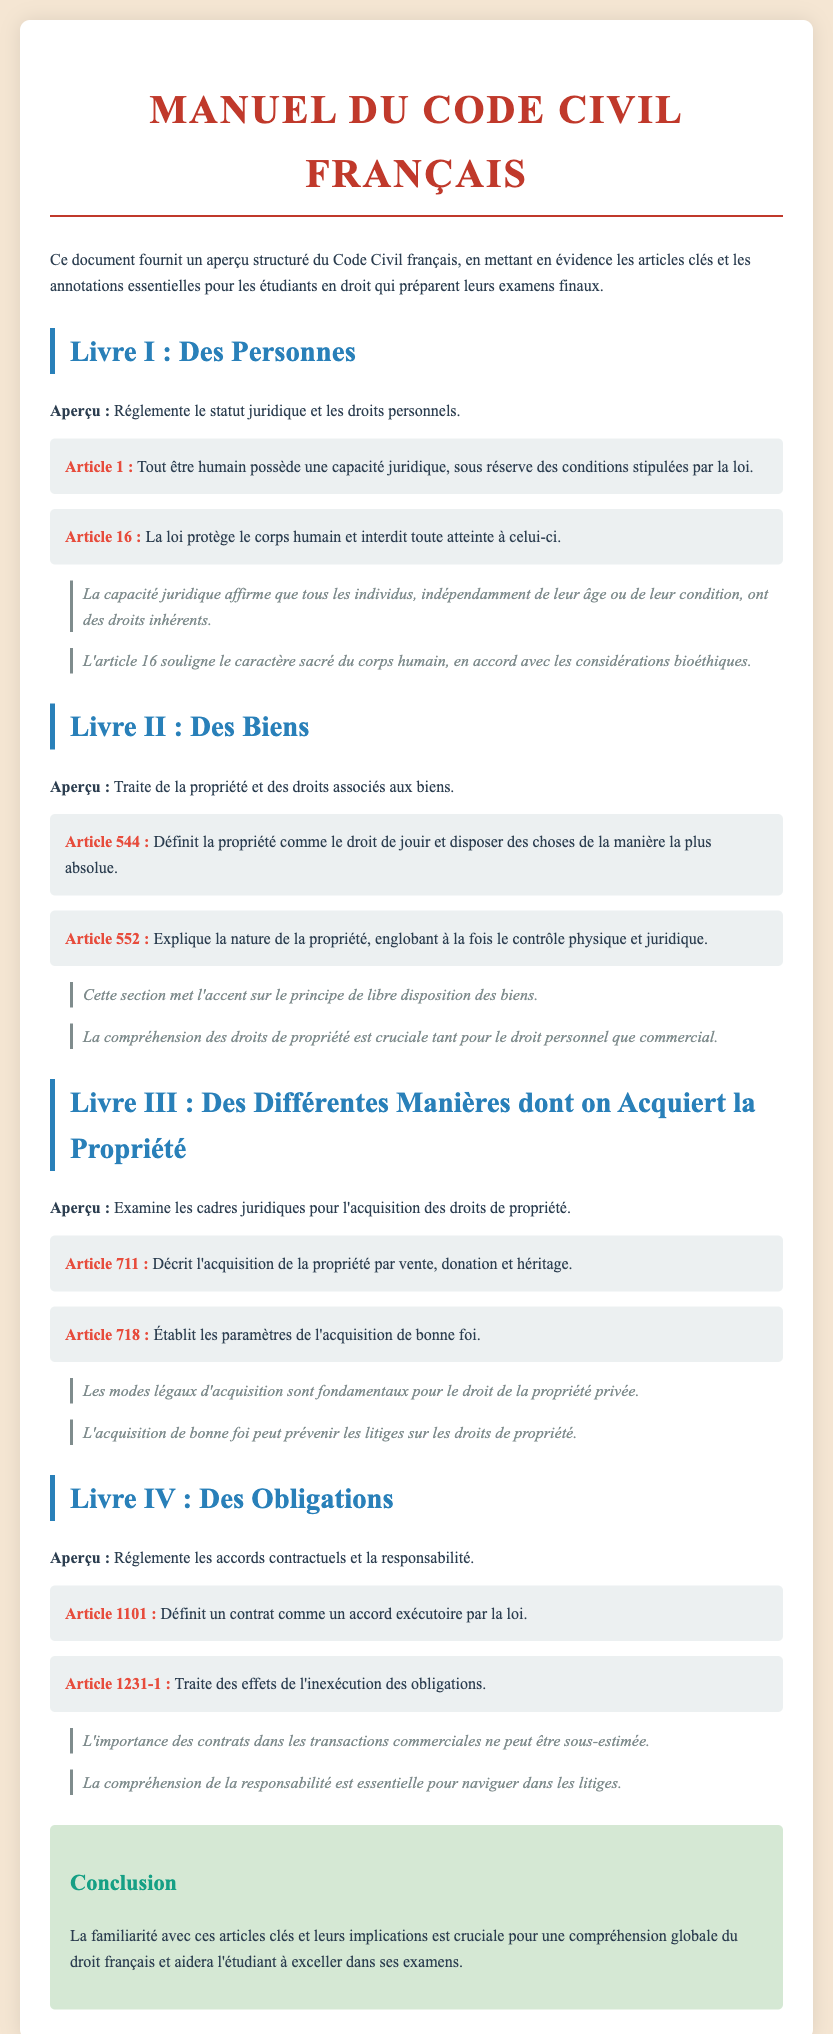Quel est le titre du document ? Le titre du document est spécifiquement mentionné en haut de la page.
Answer: Manuel du Code Civil Français Quel article stipule que tout être humain possède une capacité juridique ? L'article pertinent est précisé dans la section concernant le Livre I.
Answer: Article 1 Quel est l'article qui protège le corps humain ? L'article qui aborde la protection du corps humain fait également partie du Livre I.
Answer: Article 16 Quel droit est défini par l'Article 544 ? Ce droit est spécifié dans la section relative aux biens.
Answer: la propriété Quel article traite de l'inexécution des obligations ? Cet article est mentionné dans la section sur les obligations et les contrats.
Answer: Article 1231-1 Quel est le sujet principal du Livre II ? Le sujet principal est explicité en introduction du Livre II.
Answer: La propriété et des droits associés aux biens Quels articles abordent les différentes manières d'acquérir la propriété ? Ces articles sont évoqués dans le contexte du Livre III.
Answer: Article 711 et Article 718 Quelle est la couleur utilisée pour les titres des sections ? La couleur utilisée pour les titres est indiquée dans les styles de la page.
Answer: Bleu Quel élément est souligné par l'annotation de l'Article 16 ? L'annotation met en lumière une spécificité éthique liée à cet article.
Answer: Caractère sacré du corps humain 